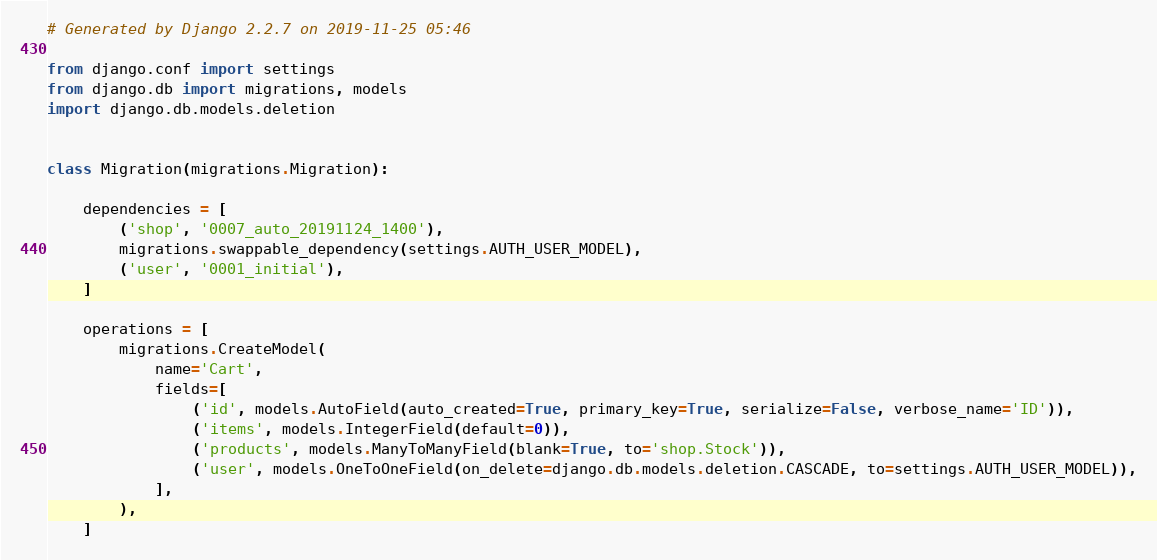<code> <loc_0><loc_0><loc_500><loc_500><_Python_># Generated by Django 2.2.7 on 2019-11-25 05:46

from django.conf import settings
from django.db import migrations, models
import django.db.models.deletion


class Migration(migrations.Migration):

    dependencies = [
        ('shop', '0007_auto_20191124_1400'),
        migrations.swappable_dependency(settings.AUTH_USER_MODEL),
        ('user', '0001_initial'),
    ]

    operations = [
        migrations.CreateModel(
            name='Cart',
            fields=[
                ('id', models.AutoField(auto_created=True, primary_key=True, serialize=False, verbose_name='ID')),
                ('items', models.IntegerField(default=0)),
                ('products', models.ManyToManyField(blank=True, to='shop.Stock')),
                ('user', models.OneToOneField(on_delete=django.db.models.deletion.CASCADE, to=settings.AUTH_USER_MODEL)),
            ],
        ),
    ]
</code> 